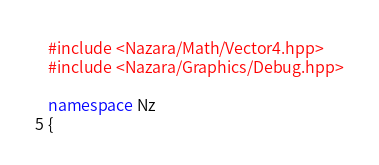<code> <loc_0><loc_0><loc_500><loc_500><_C++_>#include <Nazara/Math/Vector4.hpp>
#include <Nazara/Graphics/Debug.hpp>

namespace Nz
{</code> 